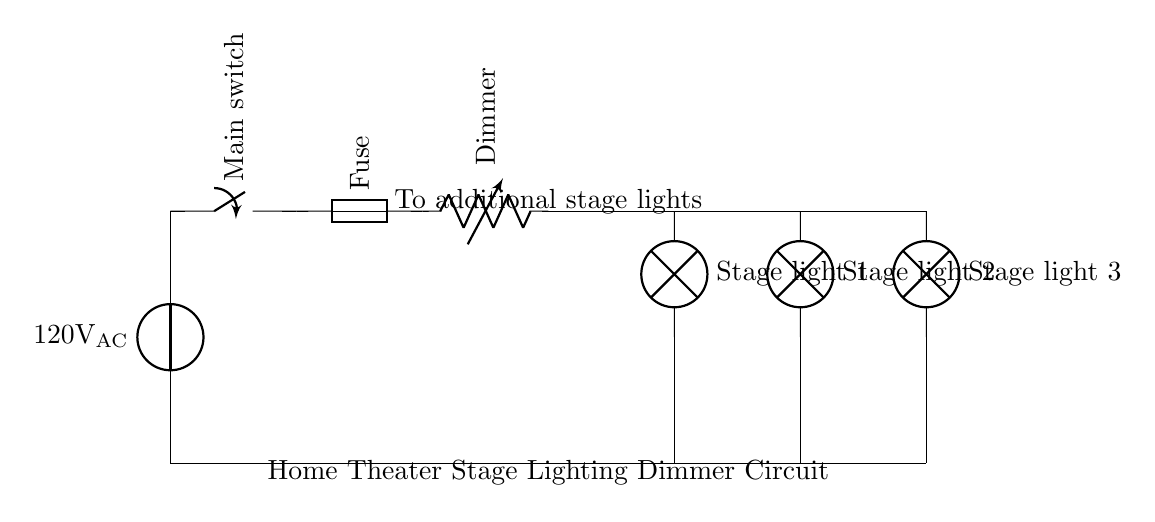What is the voltage of this circuit? The circuit shows a power source labeled as 120V AC, indicating that the voltage supplied to the circuit is alternating current at this value.
Answer: 120 volts AC What type of component is the dimmer? The dimmer is represented as a variable resistor in the diagram, which is used to adjust the brightness of the stage lights by varying the resistance in the circuit.
Answer: Variable resistor How many stage lights are connected in this circuit? The diagram shows three lamps labeled as stage light 1, stage light 2, and stage light 3, indicating that there are three stage lights in total connected to the circuit.
Answer: Three What is the purpose of the fuse in this circuit? A fuse is included to protect the circuit from overcurrent conditions. If the current exceeds a safe level, the fuse will blow, preventing damage to other components in the circuit.
Answer: Overcurrent protection What happens to the stage lights if the dimmer is turned to its maximum? When the dimmer is at its maximum setting, it allows the maximum amount of current to pass through, resulting in the stage lights being fully illuminated.
Answer: Lights are fully illuminated What would occur if the main switch is turned off? Turning off the main switch would break the circuit, cutting off the power supply to all components in the circuit, including the dimmer and stage lights, resulting in them being turned off.
Answer: Circuit is turned off 